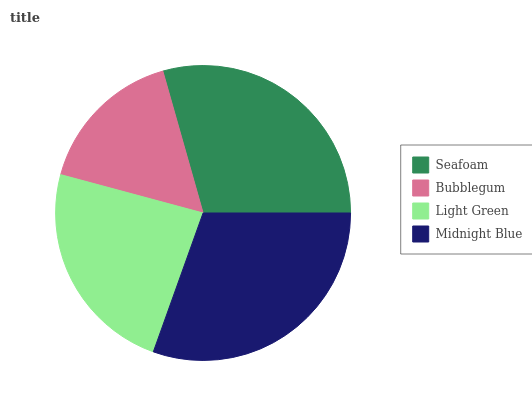Is Bubblegum the minimum?
Answer yes or no. Yes. Is Midnight Blue the maximum?
Answer yes or no. Yes. Is Light Green the minimum?
Answer yes or no. No. Is Light Green the maximum?
Answer yes or no. No. Is Light Green greater than Bubblegum?
Answer yes or no. Yes. Is Bubblegum less than Light Green?
Answer yes or no. Yes. Is Bubblegum greater than Light Green?
Answer yes or no. No. Is Light Green less than Bubblegum?
Answer yes or no. No. Is Seafoam the high median?
Answer yes or no. Yes. Is Light Green the low median?
Answer yes or no. Yes. Is Light Green the high median?
Answer yes or no. No. Is Seafoam the low median?
Answer yes or no. No. 